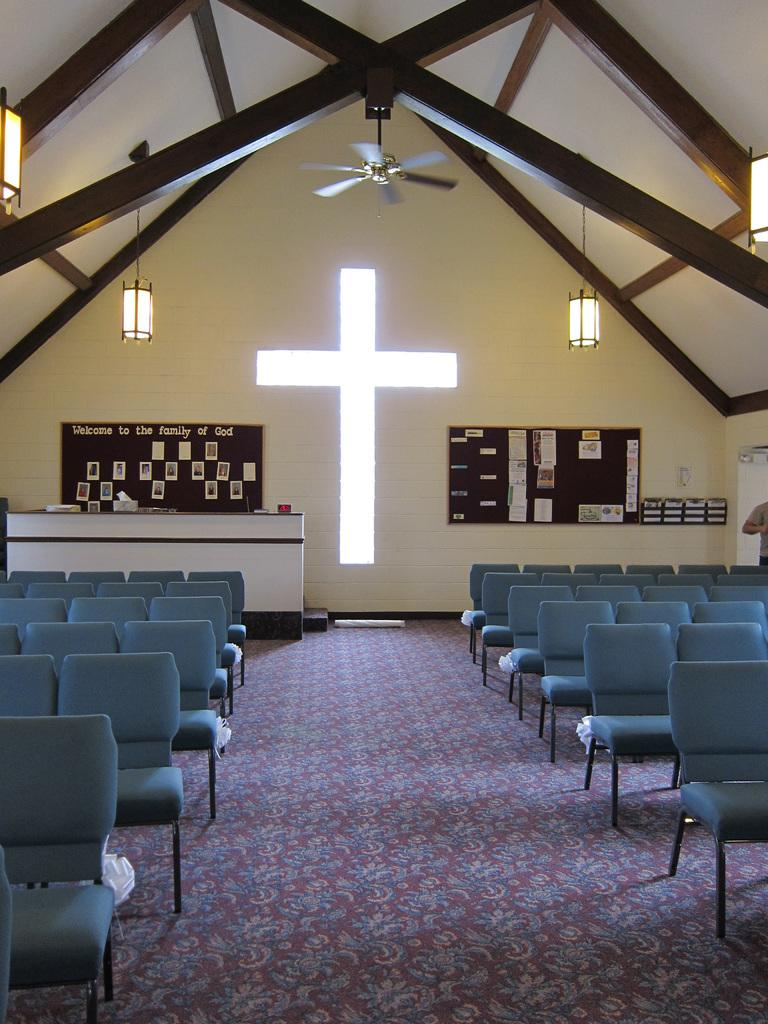What type of furniture is present in the hall in the image? There are many chairs in the hall in the image. Where is the table located in the hall? There is a table at the back of the hall. What religious symbol can be seen in the image? There is a cross symbol in the image. What type of information might be displayed on the notice boards? The notice boards on the wall might display information or announcements. Can you tell me what type of doctor is present in the image? There is no doctor present in the image. What type of science experiment is being conducted in the image? There is no science experiment or scientist present in the image. 